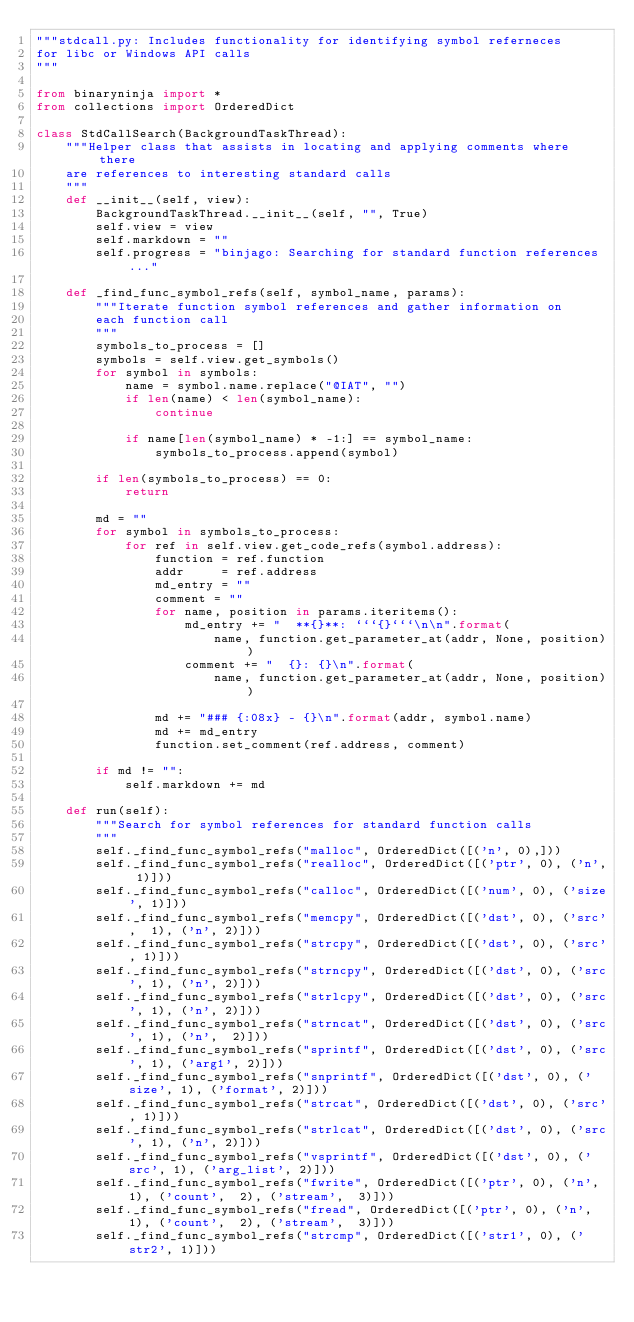<code> <loc_0><loc_0><loc_500><loc_500><_Python_>"""stdcall.py: Includes functionality for identifying symbol referneces
for libc or Windows API calls
"""

from binaryninja import *
from collections import OrderedDict

class StdCallSearch(BackgroundTaskThread):
    """Helper class that assists in locating and applying comments where there
    are references to interesting standard calls
    """
    def __init__(self, view):
        BackgroundTaskThread.__init__(self, "", True)
        self.view = view
        self.markdown = ""
        self.progress = "binjago: Searching for standard function references..."

    def _find_func_symbol_refs(self, symbol_name, params):
        """Iterate function symbol references and gather information on 
        each function call
        """
        symbols_to_process = []
        symbols = self.view.get_symbols()
        for symbol in symbols:
            name = symbol.name.replace("@IAT", "")
            if len(name) < len(symbol_name):
                continue

            if name[len(symbol_name) * -1:] == symbol_name:
                symbols_to_process.append(symbol)

        if len(symbols_to_process) == 0:
            return

        md = ""
        for symbol in symbols_to_process:
            for ref in self.view.get_code_refs(symbol.address):
                function = ref.function
                addr     = ref.address
                md_entry = ""
                comment = ""
                for name, position in params.iteritems():
                    md_entry += "  **{}**: ```{}```\n\n".format(
                        name, function.get_parameter_at(addr, None, position))
                    comment += "  {}: {}\n".format(
                        name, function.get_parameter_at(addr, None, position))

                md += "### {:08x} - {}\n".format(addr, symbol.name)
                md += md_entry
                function.set_comment(ref.address, comment)

        if md != "":
            self.markdown += md

    def run(self):
        """Search for symbol references for standard function calls
        """
        self._find_func_symbol_refs("malloc", OrderedDict([('n', 0),]))
        self._find_func_symbol_refs("realloc", OrderedDict([('ptr', 0), ('n', 1)]))
        self._find_func_symbol_refs("calloc", OrderedDict([('num', 0), ('size', 1)]))
        self._find_func_symbol_refs("memcpy", OrderedDict([('dst', 0), ('src',  1), ('n', 2)]))
        self._find_func_symbol_refs("strcpy", OrderedDict([('dst', 0), ('src', 1)]))
        self._find_func_symbol_refs("strncpy", OrderedDict([('dst', 0), ('src', 1), ('n', 2)]))
        self._find_func_symbol_refs("strlcpy", OrderedDict([('dst', 0), ('src', 1), ('n', 2)]))
        self._find_func_symbol_refs("strncat", OrderedDict([('dst', 0), ('src', 1), ('n',  2)]))
        self._find_func_symbol_refs("sprintf", OrderedDict([('dst', 0), ('src', 1), ('arg1', 2)]))
        self._find_func_symbol_refs("snprintf", OrderedDict([('dst', 0), ('size', 1), ('format', 2)]))
        self._find_func_symbol_refs("strcat", OrderedDict([('dst', 0), ('src', 1)]))
        self._find_func_symbol_refs("strlcat", OrderedDict([('dst', 0), ('src', 1), ('n', 2)]))
        self._find_func_symbol_refs("vsprintf", OrderedDict([('dst', 0), ('src', 1), ('arg_list', 2)]))
        self._find_func_symbol_refs("fwrite", OrderedDict([('ptr', 0), ('n', 1), ('count',  2), ('stream',  3)]))
        self._find_func_symbol_refs("fread", OrderedDict([('ptr', 0), ('n', 1), ('count',  2), ('stream',  3)]))
        self._find_func_symbol_refs("strcmp", OrderedDict([('str1', 0), ('str2', 1)]))</code> 